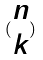Convert formula to latex. <formula><loc_0><loc_0><loc_500><loc_500>( \begin{matrix} n \\ k \end{matrix} )</formula> 